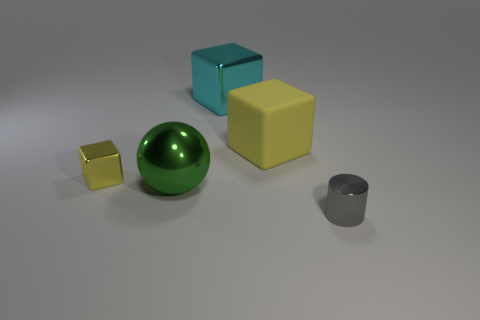Add 3 purple matte objects. How many objects exist? 8 Subtract all big metal cubes. How many cubes are left? 2 Subtract all cubes. How many objects are left? 2 Subtract all brown cylinders. Subtract all brown spheres. How many cylinders are left? 1 Subtract all green balls. How many brown cubes are left? 0 Subtract all tiny blue rubber cylinders. Subtract all green spheres. How many objects are left? 4 Add 5 big green shiny objects. How many big green shiny objects are left? 6 Add 5 large green matte spheres. How many large green matte spheres exist? 5 Subtract all cyan blocks. How many blocks are left? 2 Subtract 0 purple spheres. How many objects are left? 5 